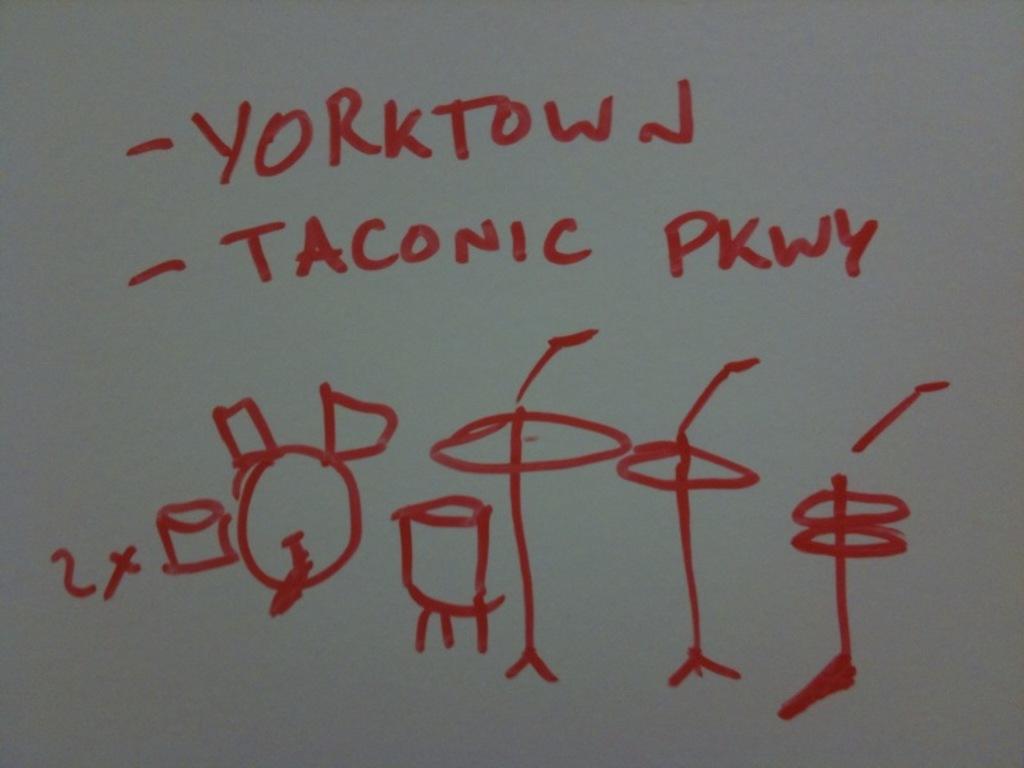How many words are written on the white board?
Your answer should be very brief. 3. What does the bottom bullet point say?
Make the answer very short. Taconic pkwy. 